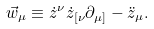Convert formula to latex. <formula><loc_0><loc_0><loc_500><loc_500>\vec { w } _ { \mu } \equiv \dot { z } ^ { \nu } \dot { z } _ { [ \nu } \partial _ { \mu ] } - \ddot { z } _ { \mu } .</formula> 